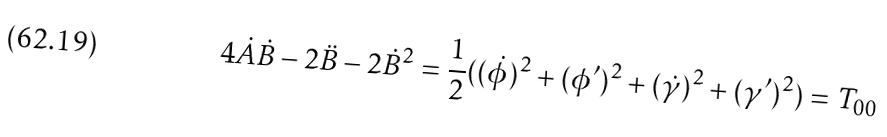<formula> <loc_0><loc_0><loc_500><loc_500>4 \dot { A } \dot { B } - 2 \ddot { B } - 2 \dot { B } ^ { 2 } = \frac { 1 } { 2 } ( ( \dot { \phi } ) ^ { 2 } + ( \phi ^ { \prime } ) ^ { 2 } + ( \dot { \gamma } ) ^ { 2 } + ( \gamma ^ { \prime } ) ^ { 2 } ) = T _ { 0 0 }</formula> 